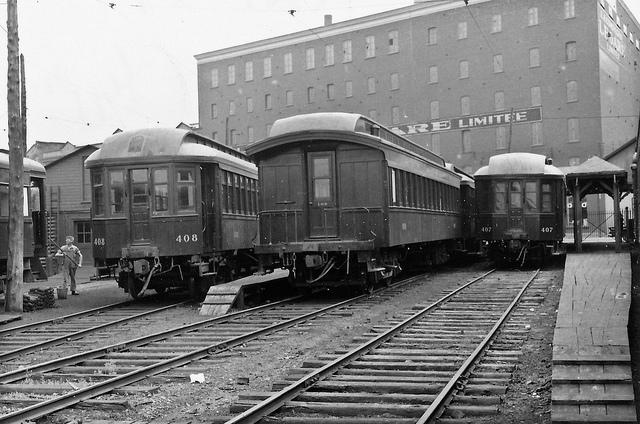What are the pants type the man is wearing? overalls 